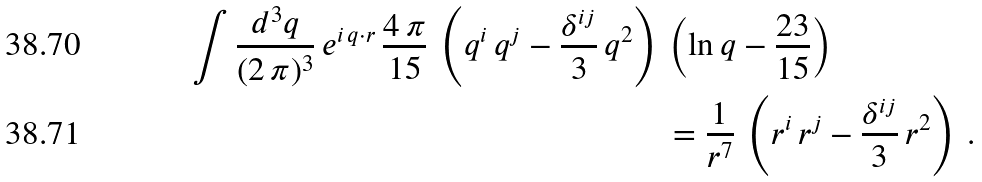<formula> <loc_0><loc_0><loc_500><loc_500>\int \frac { d ^ { 3 } q } { ( 2 \, \pi ) ^ { 3 } } \, e ^ { i \, q \cdot r } \, \frac { 4 \, \pi } { 1 5 } \, \left ( q ^ { i } \, q ^ { j } - \frac { \delta ^ { i j } } { 3 } \, q ^ { 2 } \right ) \, & \left ( \ln q - \frac { 2 3 } { 1 5 } \right ) \\ & = \frac { 1 } { r ^ { 7 } } \, \left ( r ^ { i } \, r ^ { j } - \frac { \delta ^ { i j } } { 3 } \, r ^ { 2 } \right ) \, .</formula> 